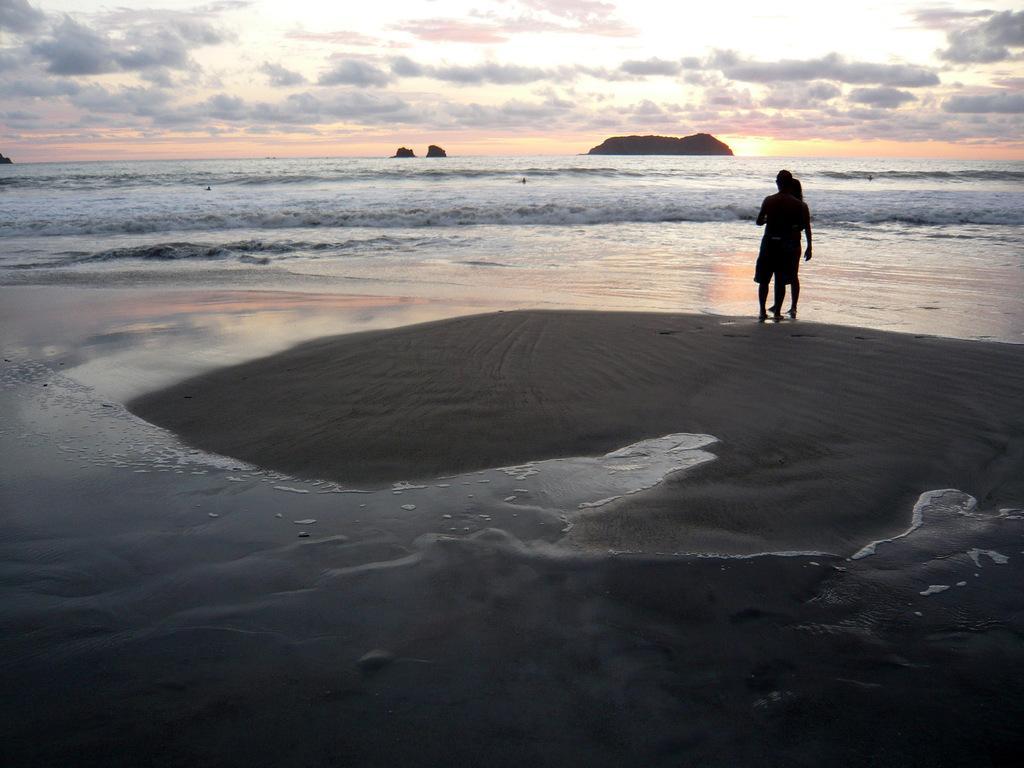How would you summarize this image in a sentence or two? In this image we can see there are two persons standing. And we can see the rocks and water. In the background, we can see the cloudy sky. 